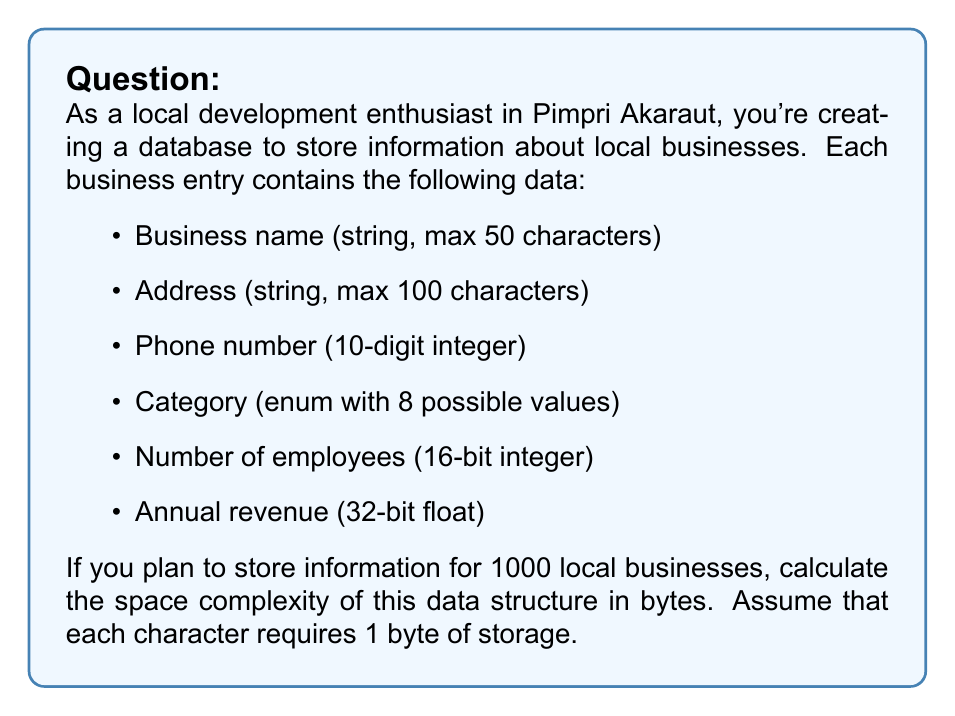Give your solution to this math problem. Let's break down the space required for each component of a business entry:

1. Business name: 
   Max 50 characters * 1 byte/character = 50 bytes

2. Address: 
   Max 100 characters * 1 byte/character = 100 bytes

3. Phone number: 
   10-digit integer requires 4 bytes (32 bits)

4. Category: 
   Enum with 8 possible values can be stored in 1 byte (8 bits)

5. Number of employees: 
   16-bit integer requires 2 bytes

6. Annual revenue: 
   32-bit float requires 4 bytes

Total space for one business entry:
$$50 + 100 + 4 + 1 + 2 + 4 = 161\text{ bytes}$$

For 1000 businesses:
$$1000 * 161 = 161,000\text{ bytes}$$

The space complexity can be expressed as $O(n)$, where $n$ is the number of businesses, because the space required grows linearly with the number of entries.
Answer: 161,000 bytes or 161 KB. The space complexity is $O(n)$. 